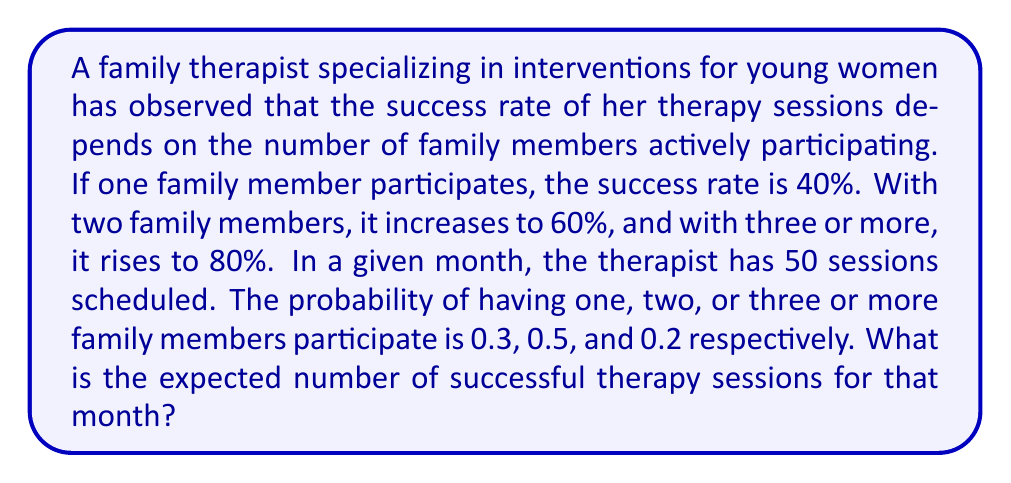Help me with this question. Let's approach this step-by-step:

1) First, we need to calculate the probability of success for each scenario:

   P(Success | 1 member) = 0.40
   P(Success | 2 members) = 0.60
   P(Success | 3+ members) = 0.80

2) We also know the probability of each scenario occurring:

   P(1 member) = 0.3
   P(2 members) = 0.5
   P(3+ members) = 0.2

3) We can calculate the overall probability of success using the law of total probability:

   $$P(\text{Success}) = P(\text{Success}|1) \cdot P(1) + P(\text{Success}|2) \cdot P(2) + P(\text{Success}|3+) \cdot P(3+)$$

4) Substituting the values:

   $$P(\text{Success}) = 0.40 \cdot 0.3 + 0.60 \cdot 0.5 + 0.80 \cdot 0.2$$

5) Calculating:

   $$P(\text{Success}) = 0.12 + 0.30 + 0.16 = 0.58$$

6) The expected number of successful sessions is the probability of success multiplied by the total number of sessions:

   $$E(\text{Successful Sessions}) = P(\text{Success}) \cdot \text{Total Sessions}$$

7) Substituting the values:

   $$E(\text{Successful Sessions}) = 0.58 \cdot 50 = 29$$

Therefore, the expected number of successful therapy sessions for that month is 29.
Answer: 29 sessions 